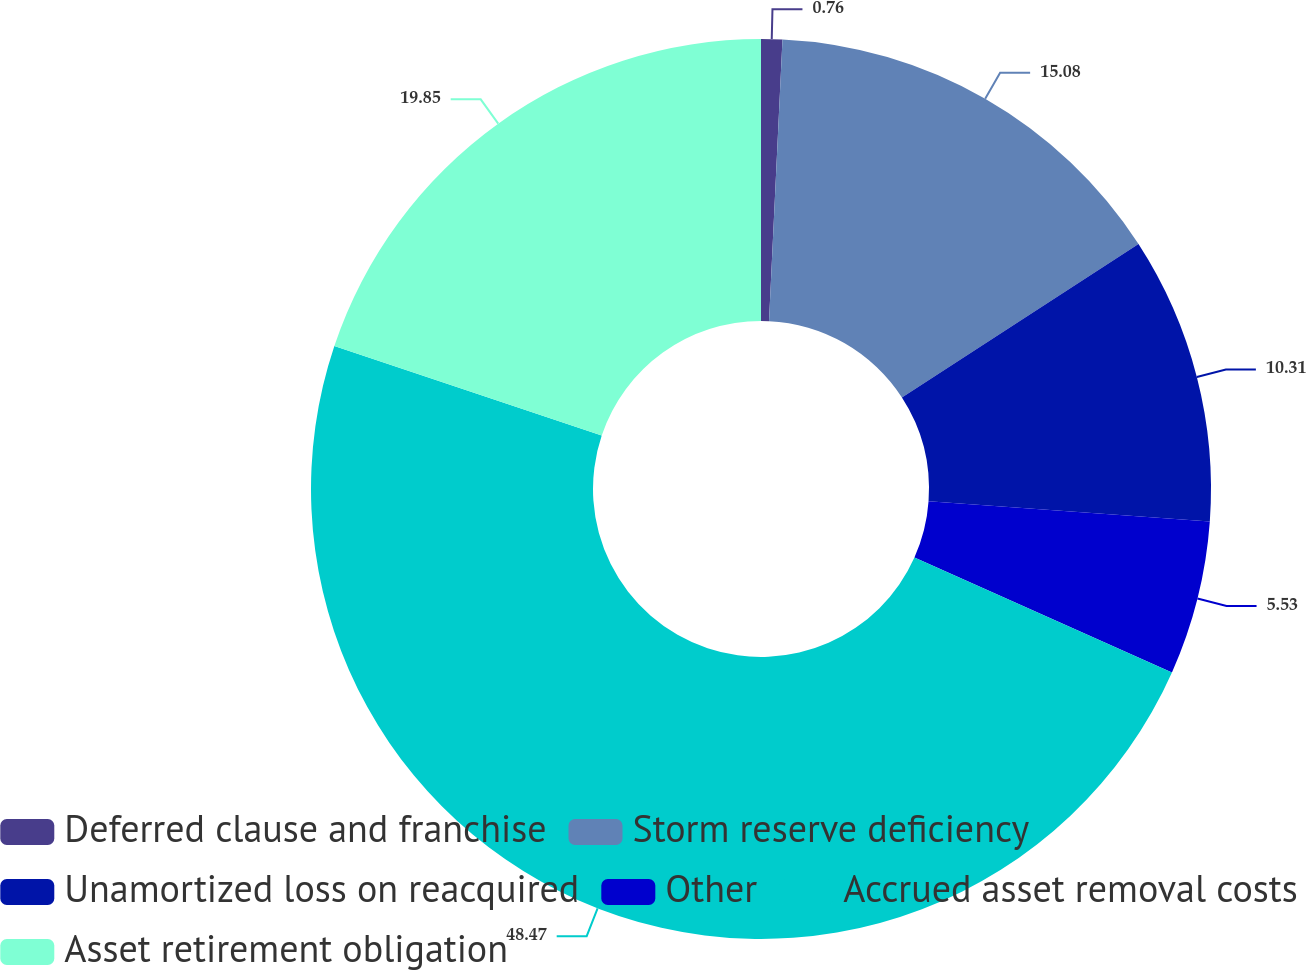<chart> <loc_0><loc_0><loc_500><loc_500><pie_chart><fcel>Deferred clause and franchise<fcel>Storm reserve deficiency<fcel>Unamortized loss on reacquired<fcel>Other<fcel>Accrued asset removal costs<fcel>Asset retirement obligation<nl><fcel>0.76%<fcel>15.08%<fcel>10.31%<fcel>5.53%<fcel>48.47%<fcel>19.85%<nl></chart> 